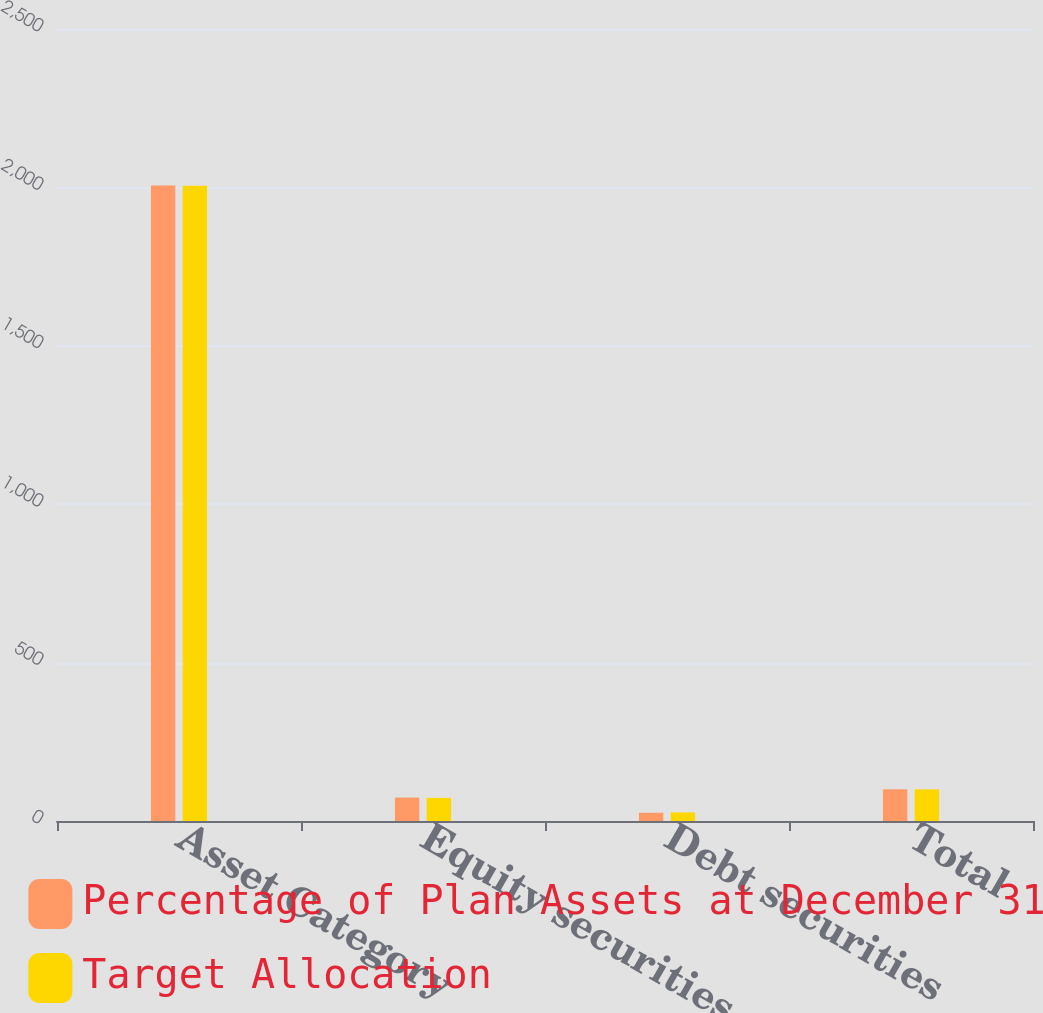<chart> <loc_0><loc_0><loc_500><loc_500><stacked_bar_chart><ecel><fcel>Asset Category<fcel>Equity securities<fcel>Debt securities<fcel>Total<nl><fcel>Percentage of Plan Assets at December 31<fcel>2006<fcel>74<fcel>26<fcel>100<nl><fcel>Target Allocation<fcel>2005<fcel>73<fcel>27<fcel>100<nl></chart> 